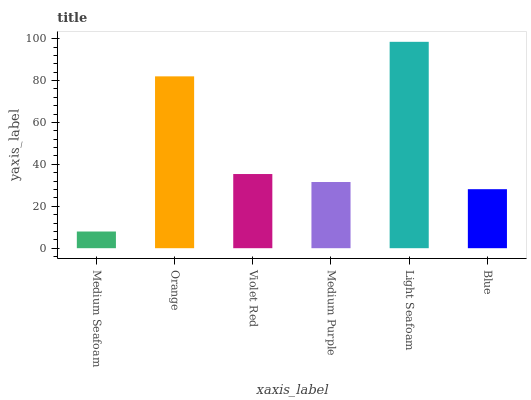Is Medium Seafoam the minimum?
Answer yes or no. Yes. Is Light Seafoam the maximum?
Answer yes or no. Yes. Is Orange the minimum?
Answer yes or no. No. Is Orange the maximum?
Answer yes or no. No. Is Orange greater than Medium Seafoam?
Answer yes or no. Yes. Is Medium Seafoam less than Orange?
Answer yes or no. Yes. Is Medium Seafoam greater than Orange?
Answer yes or no. No. Is Orange less than Medium Seafoam?
Answer yes or no. No. Is Violet Red the high median?
Answer yes or no. Yes. Is Medium Purple the low median?
Answer yes or no. Yes. Is Light Seafoam the high median?
Answer yes or no. No. Is Violet Red the low median?
Answer yes or no. No. 